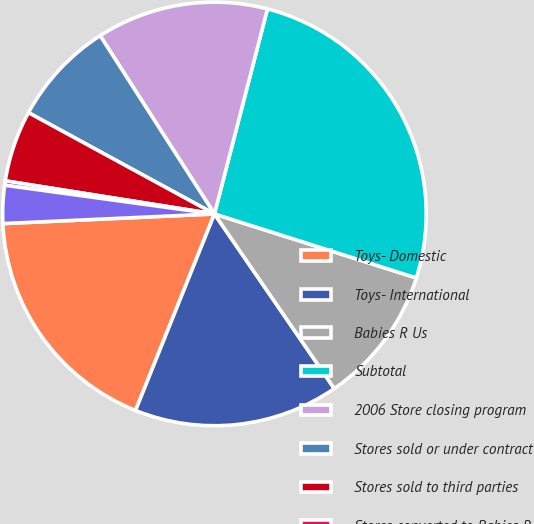Convert chart to OTSL. <chart><loc_0><loc_0><loc_500><loc_500><pie_chart><fcel>Toys- Domestic<fcel>Toys- International<fcel>Babies R Us<fcel>Subtotal<fcel>2006 Store closing program<fcel>Stores sold or under contract<fcel>Stores sold to third parties<fcel>Stores converted to Babies R<fcel>Remaining stores to be leased<nl><fcel>18.2%<fcel>15.65%<fcel>10.54%<fcel>25.86%<fcel>13.1%<fcel>7.99%<fcel>5.44%<fcel>0.33%<fcel>2.89%<nl></chart> 